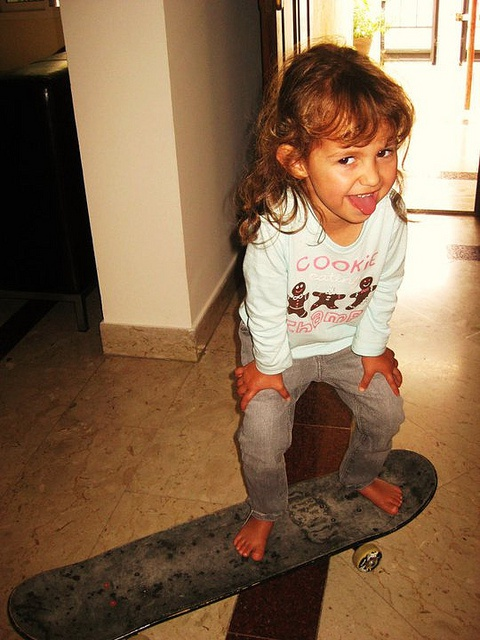Describe the objects in this image and their specific colors. I can see people in black, beige, maroon, and gray tones, skateboard in black, maroon, and gray tones, and potted plant in black, beige, khaki, and orange tones in this image. 